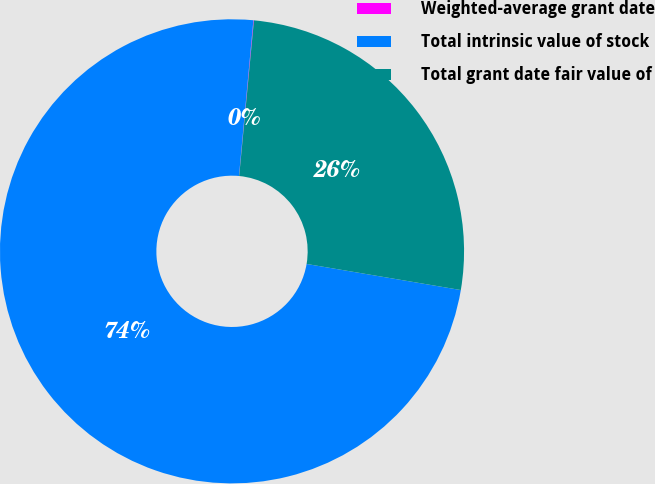<chart> <loc_0><loc_0><loc_500><loc_500><pie_chart><fcel>Weighted-average grant date<fcel>Total intrinsic value of stock<fcel>Total grant date fair value of<nl><fcel>0.04%<fcel>73.8%<fcel>26.16%<nl></chart> 